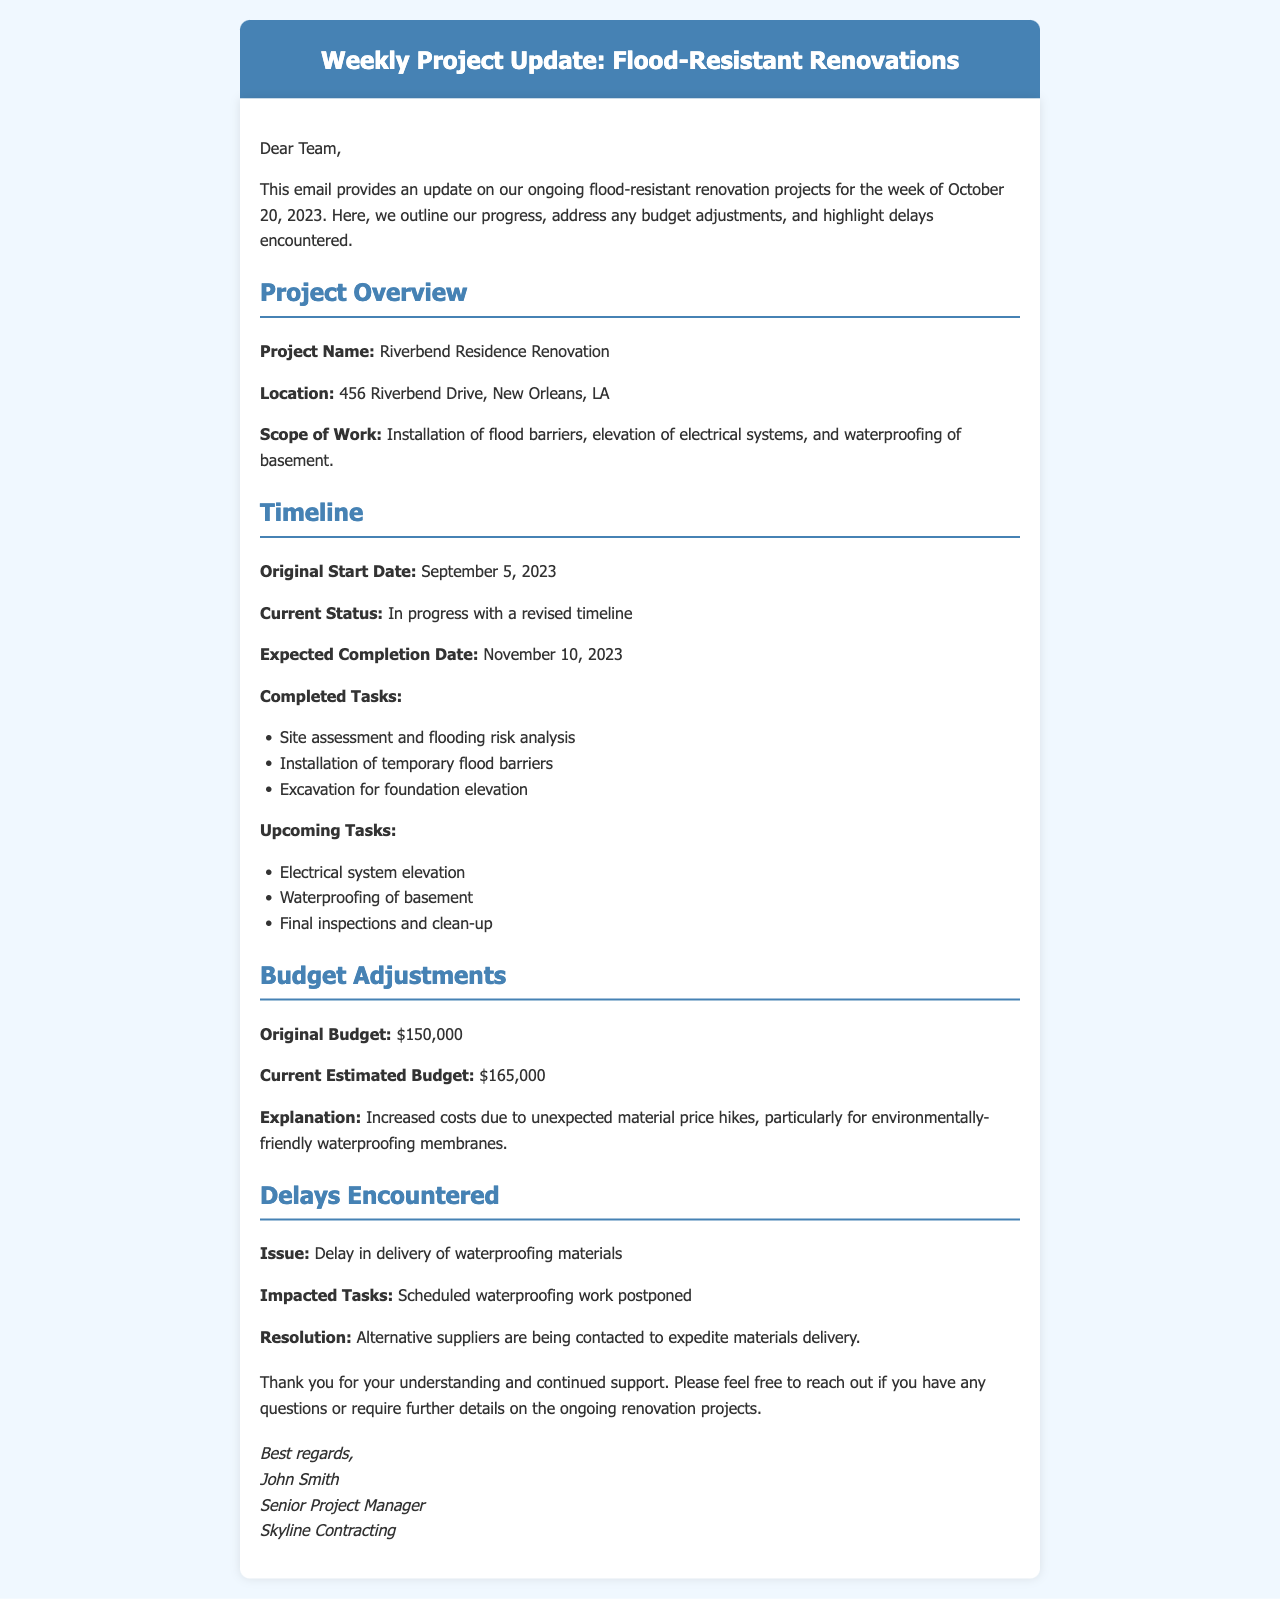What is the project name? The project name is clearly stated in the document section under "Project Overview."
Answer: Riverbend Residence Renovation What is the current estimated budget? The current estimated budget is mentioned in the "Budget Adjustments" section of the email.
Answer: $165,000 What is the expected completion date? The expected completion date is outlined in the "Timeline" section of the email.
Answer: November 10, 2023 What task was delayed due to material issues? The email specifies that waterproofing work was postponed due to delays in material delivery.
Answer: Waterproofing work What was the original budget for the project? The original budget is stated explicitly in the "Budget Adjustments" section of the document.
Answer: $150,000 Which task has already been completed last week? The "Timeline" section lists tasks completed, including the site assessment.
Answer: Site assessment and flooding risk analysis What is being done to resolve the delay issue? The document mentions contacting alternative suppliers as a resolution to the delay.
Answer: Contacting alternative suppliers What is the location of the project? The project location is detailed in the "Project Overview" section of the email.
Answer: 456 Riverbend Drive, New Orleans, LA What is the name of the sender? The sender's name is provided at the end of the email under the signature section.
Answer: John Smith 